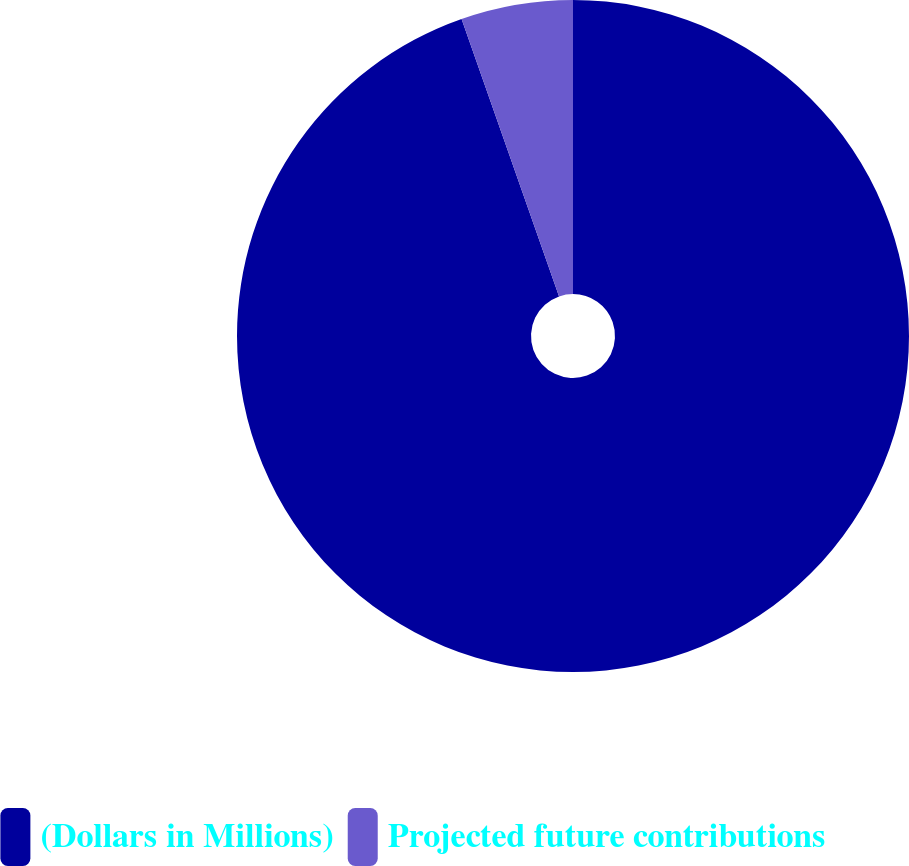Convert chart to OTSL. <chart><loc_0><loc_0><loc_500><loc_500><pie_chart><fcel>(Dollars in Millions)<fcel>Projected future contributions<nl><fcel>94.62%<fcel>5.38%<nl></chart> 